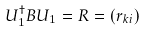Convert formula to latex. <formula><loc_0><loc_0><loc_500><loc_500>U _ { 1 } ^ { \dagger } B U _ { 1 } = R = ( r _ { k i } )</formula> 